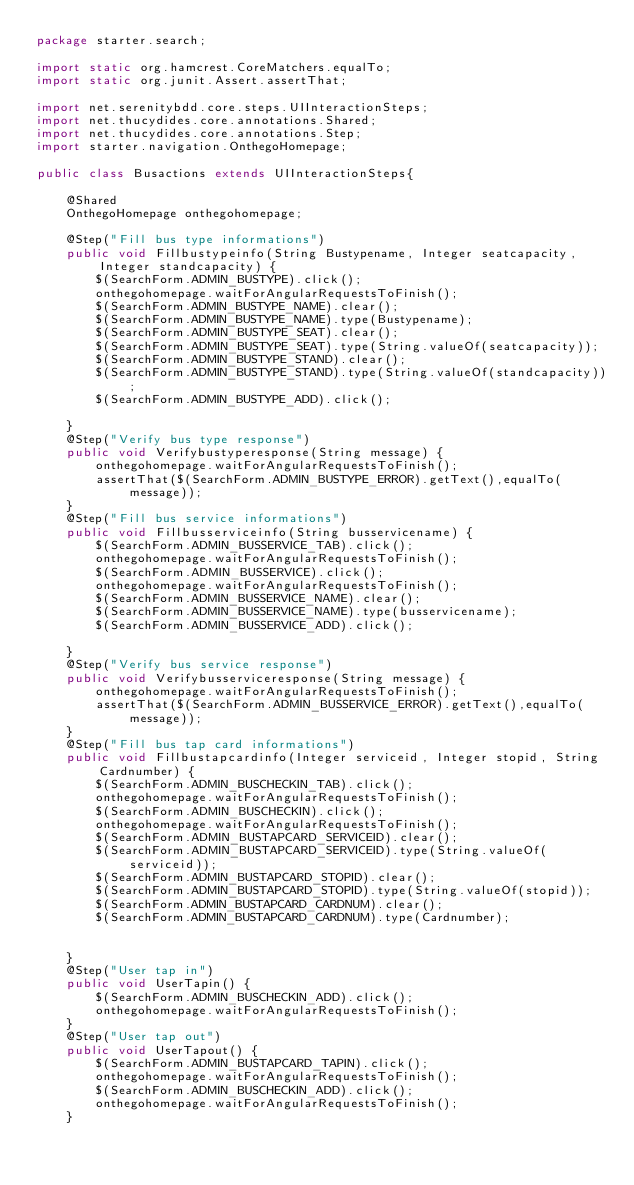Convert code to text. <code><loc_0><loc_0><loc_500><loc_500><_Java_>package starter.search;

import static org.hamcrest.CoreMatchers.equalTo;
import static org.junit.Assert.assertThat;

import net.serenitybdd.core.steps.UIInteractionSteps;
import net.thucydides.core.annotations.Shared;
import net.thucydides.core.annotations.Step;
import starter.navigation.OnthegoHomepage;

public class Busactions extends UIInteractionSteps{

	@Shared
	OnthegoHomepage onthegohomepage;

	@Step("Fill bus type informations")
	public void Fillbustypeinfo(String Bustypename, Integer seatcapacity, Integer standcapacity) {
		$(SearchForm.ADMIN_BUSTYPE).click();
		onthegohomepage.waitForAngularRequestsToFinish();
		$(SearchForm.ADMIN_BUSTYPE_NAME).clear();
		$(SearchForm.ADMIN_BUSTYPE_NAME).type(Bustypename);
		$(SearchForm.ADMIN_BUSTYPE_SEAT).clear();
		$(SearchForm.ADMIN_BUSTYPE_SEAT).type(String.valueOf(seatcapacity));
		$(SearchForm.ADMIN_BUSTYPE_STAND).clear();
		$(SearchForm.ADMIN_BUSTYPE_STAND).type(String.valueOf(standcapacity));
		$(SearchForm.ADMIN_BUSTYPE_ADD).click();

	}
	@Step("Verify bus type response")
	public void Verifybustyperesponse(String message) {
		onthegohomepage.waitForAngularRequestsToFinish();
		assertThat($(SearchForm.ADMIN_BUSTYPE_ERROR).getText(),equalTo(message));
	}
	@Step("Fill bus service informations")
	public void Fillbusserviceinfo(String busservicename) {
		$(SearchForm.ADMIN_BUSSERVICE_TAB).click();
		onthegohomepage.waitForAngularRequestsToFinish();
		$(SearchForm.ADMIN_BUSSERVICE).click();
		onthegohomepage.waitForAngularRequestsToFinish();
		$(SearchForm.ADMIN_BUSSERVICE_NAME).clear();
		$(SearchForm.ADMIN_BUSSERVICE_NAME).type(busservicename);
		$(SearchForm.ADMIN_BUSSERVICE_ADD).click();

	}
	@Step("Verify bus service response")
	public void Verifybusserviceresponse(String message) {
		onthegohomepage.waitForAngularRequestsToFinish();
		assertThat($(SearchForm.ADMIN_BUSSERVICE_ERROR).getText(),equalTo(message));
	}
	@Step("Fill bus tap card informations")
	public void Fillbustapcardinfo(Integer serviceid, Integer stopid, String Cardnumber) {
		$(SearchForm.ADMIN_BUSCHECKIN_TAB).click();
		onthegohomepage.waitForAngularRequestsToFinish();
		$(SearchForm.ADMIN_BUSCHECKIN).click();
		onthegohomepage.waitForAngularRequestsToFinish();
		$(SearchForm.ADMIN_BUSTAPCARD_SERVICEID).clear();
		$(SearchForm.ADMIN_BUSTAPCARD_SERVICEID).type(String.valueOf(serviceid));
		$(SearchForm.ADMIN_BUSTAPCARD_STOPID).clear();
		$(SearchForm.ADMIN_BUSTAPCARD_STOPID).type(String.valueOf(stopid));
		$(SearchForm.ADMIN_BUSTAPCARD_CARDNUM).clear();
		$(SearchForm.ADMIN_BUSTAPCARD_CARDNUM).type(Cardnumber);
		

	}
	@Step("User tap in")
	public void UserTapin() {
		$(SearchForm.ADMIN_BUSCHECKIN_ADD).click();
		onthegohomepage.waitForAngularRequestsToFinish();
	}
	@Step("User tap out")
	public void UserTapout() {
		$(SearchForm.ADMIN_BUSTAPCARD_TAPIN).click();
		onthegohomepage.waitForAngularRequestsToFinish();
		$(SearchForm.ADMIN_BUSCHECKIN_ADD).click();
		onthegohomepage.waitForAngularRequestsToFinish();
	}</code> 